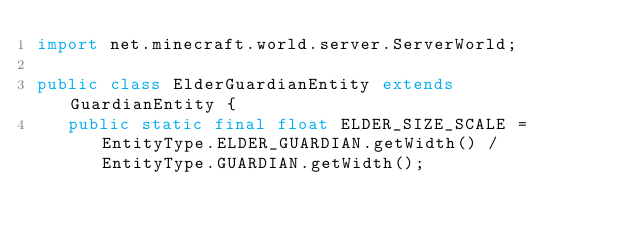<code> <loc_0><loc_0><loc_500><loc_500><_Java_>import net.minecraft.world.server.ServerWorld;

public class ElderGuardianEntity extends GuardianEntity {
   public static final float ELDER_SIZE_SCALE = EntityType.ELDER_GUARDIAN.getWidth() / EntityType.GUARDIAN.getWidth();
</code> 